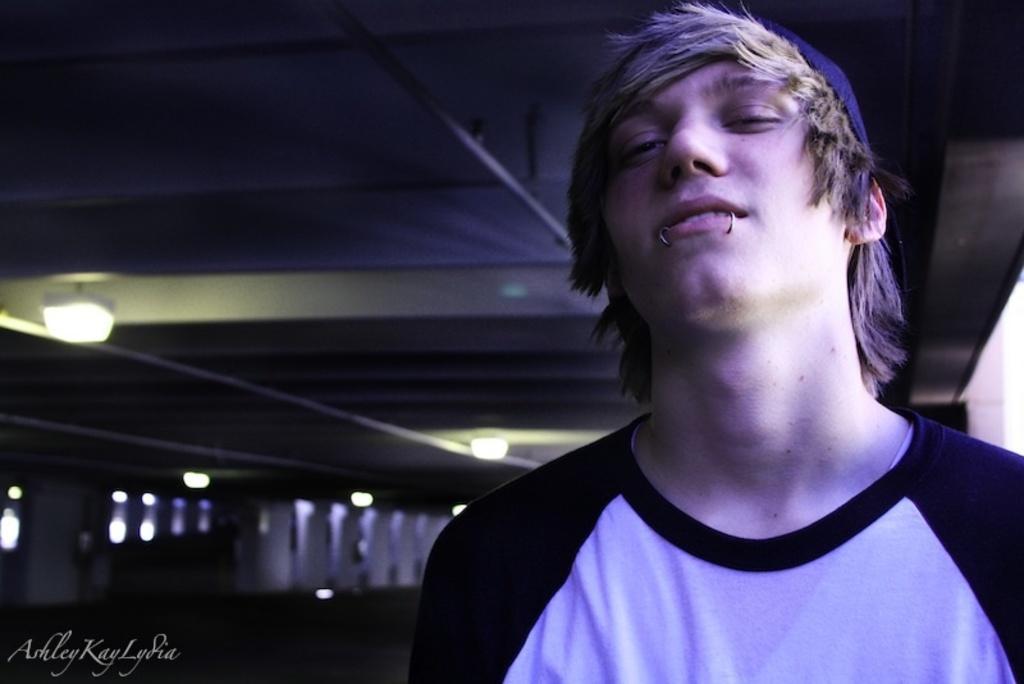Could you give a brief overview of what you see in this image? In this image we can see a man wearing the black and white t shirt. We can also see the ceiling and also lights. In the bottom left corner there is text. 